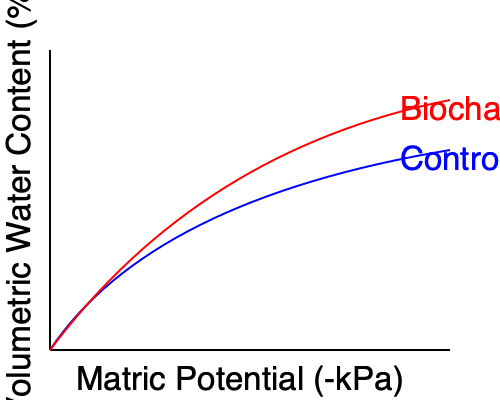Based on the moisture retention curves shown in the graph, how does the addition of biochar affect the soil's water retention capacity at high matric potentials (near saturation)? Explain the underlying mechanism for this change. To answer this question, we need to analyze the moisture retention curves and understand the relationship between biochar addition and soil water dynamics:

1. Observe the curves: The red curve (biochar-amended soil) is higher than the blue curve (control soil) at low matric potential values (right side of the graph).

2. Interpret the graph: Higher volumetric water content at a given matric potential indicates greater water retention capacity.

3. Focus on high matric potentials: At the right side of the graph (near saturation), the biochar-amended soil curve shows a higher volumetric water content compared to the control soil.

4. Underlying mechanism:
   a) Biochar has a highly porous structure with a large surface area.
   b) This porosity increases the soil's overall porosity.
   c) The increased porosity provides more space for water storage, especially in the larger pores that retain water at high matric potentials.
   d) Biochar's surface chemistry (e.g., hydrophilic functional groups) can also contribute to improved water retention.

5. Result: The biochar-amended soil can hold more water at near-saturation conditions, improving the soil's water retention capacity at high matric potentials.

This effect is particularly beneficial for plant-available water, as it increases the amount of water held in the soil that plants can easily access.
Answer: Biochar increases soil water retention capacity at high matric potentials by enhancing soil porosity and providing additional water storage space. 